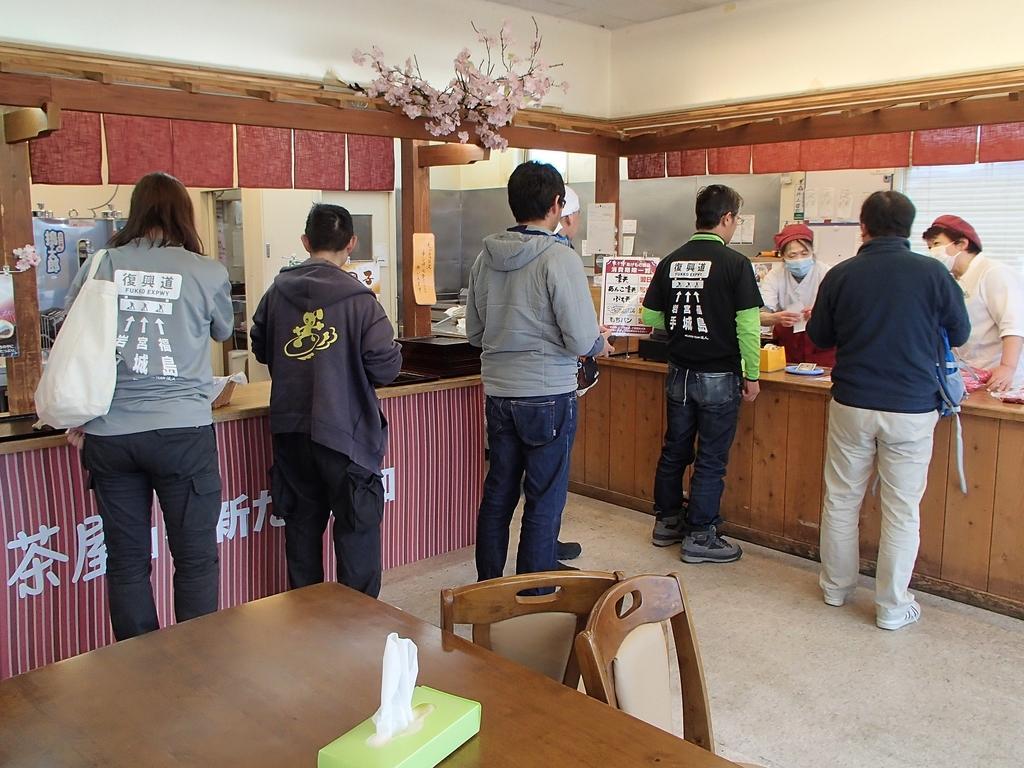How would you summarize this image in a sentence or two? Few people are standing in a line. On the left side there is a dining table and chairs. 